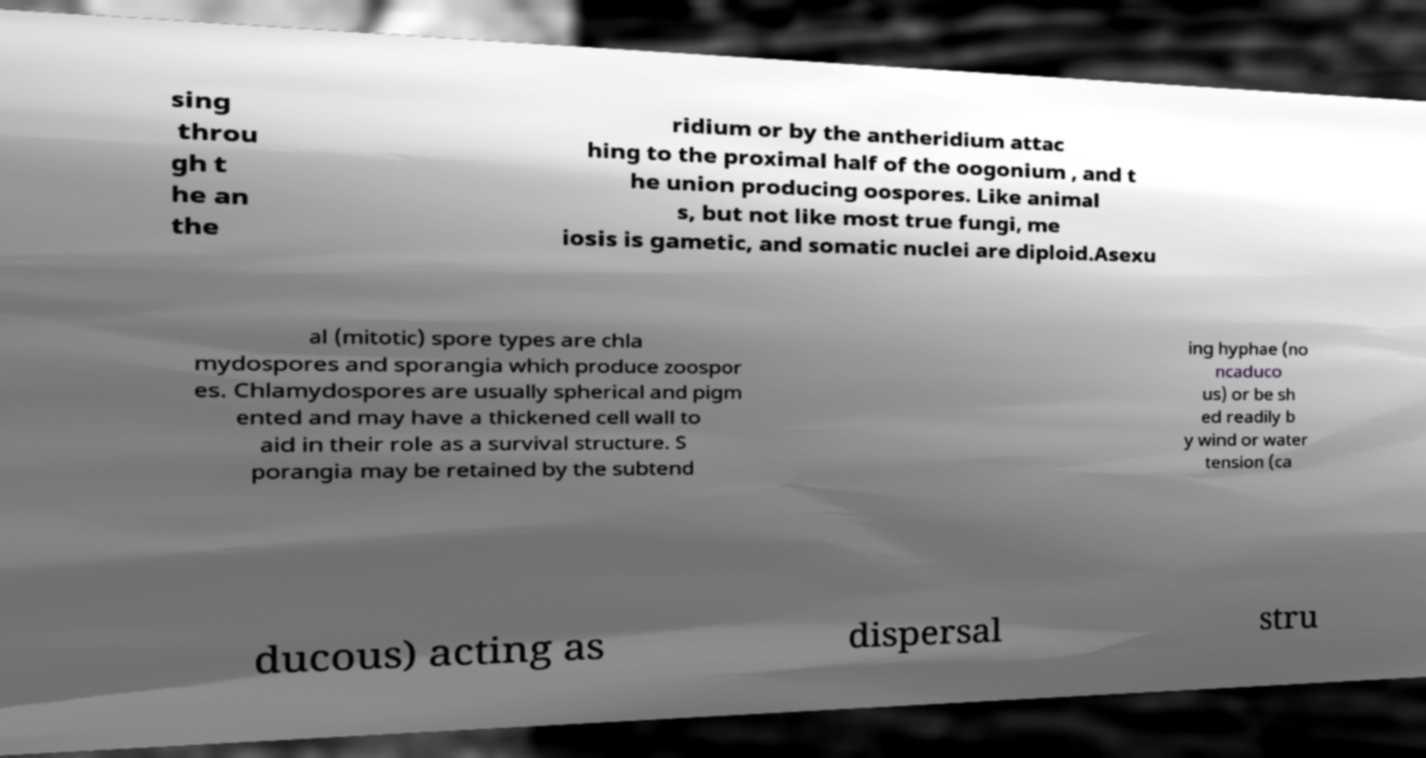Can you accurately transcribe the text from the provided image for me? sing throu gh t he an the ridium or by the antheridium attac hing to the proximal half of the oogonium , and t he union producing oospores. Like animal s, but not like most true fungi, me iosis is gametic, and somatic nuclei are diploid.Asexu al (mitotic) spore types are chla mydospores and sporangia which produce zoospor es. Chlamydospores are usually spherical and pigm ented and may have a thickened cell wall to aid in their role as a survival structure. S porangia may be retained by the subtend ing hyphae (no ncaduco us) or be sh ed readily b y wind or water tension (ca ducous) acting as dispersal stru 